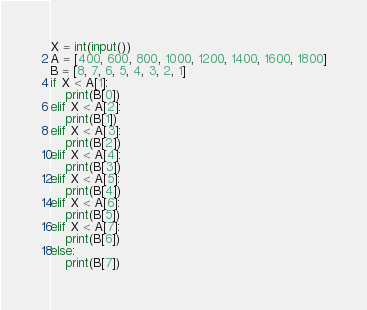<code> <loc_0><loc_0><loc_500><loc_500><_Python_>X = int(input())
A = [400, 600, 800, 1000, 1200, 1400, 1600, 1800]
B = [8, 7, 6, 5, 4, 3, 2, 1]
if X < A[1]:
    print(B[0])
elif X < A[2]:
    print(B[1])
elif X < A[3]:
    print(B[2])
elif X < A[4]:
    print(B[3])
elif X < A[5]:
    print(B[4])
elif X < A[6]:
    print(B[5])
elif X < A[7]:
    print(B[6])
else:
    print(B[7])
</code> 